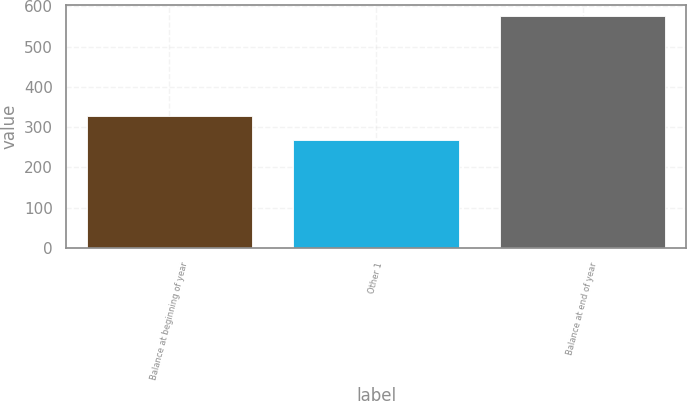Convert chart. <chart><loc_0><loc_0><loc_500><loc_500><bar_chart><fcel>Balance at beginning of year<fcel>Other 1<fcel>Balance at end of year<nl><fcel>329<fcel>267<fcel>576<nl></chart> 